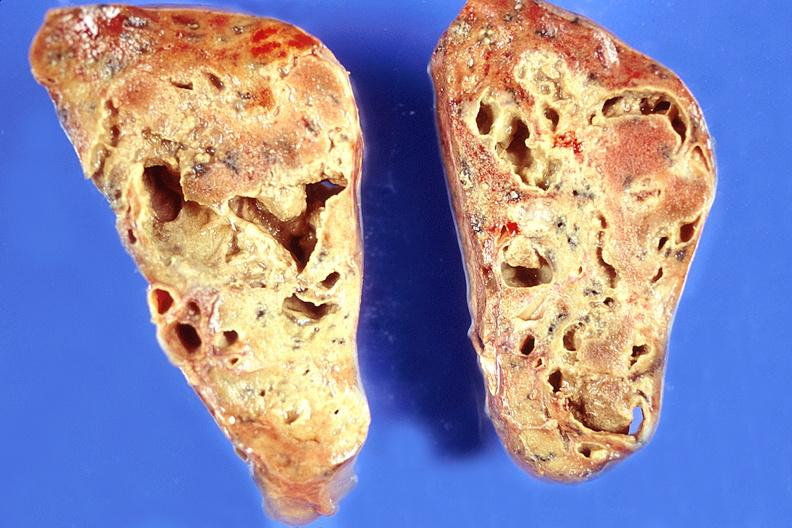does this image show lung, chronic abscesses?
Answer the question using a single word or phrase. Yes 